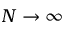<formula> <loc_0><loc_0><loc_500><loc_500>N \rightarrow \infty</formula> 